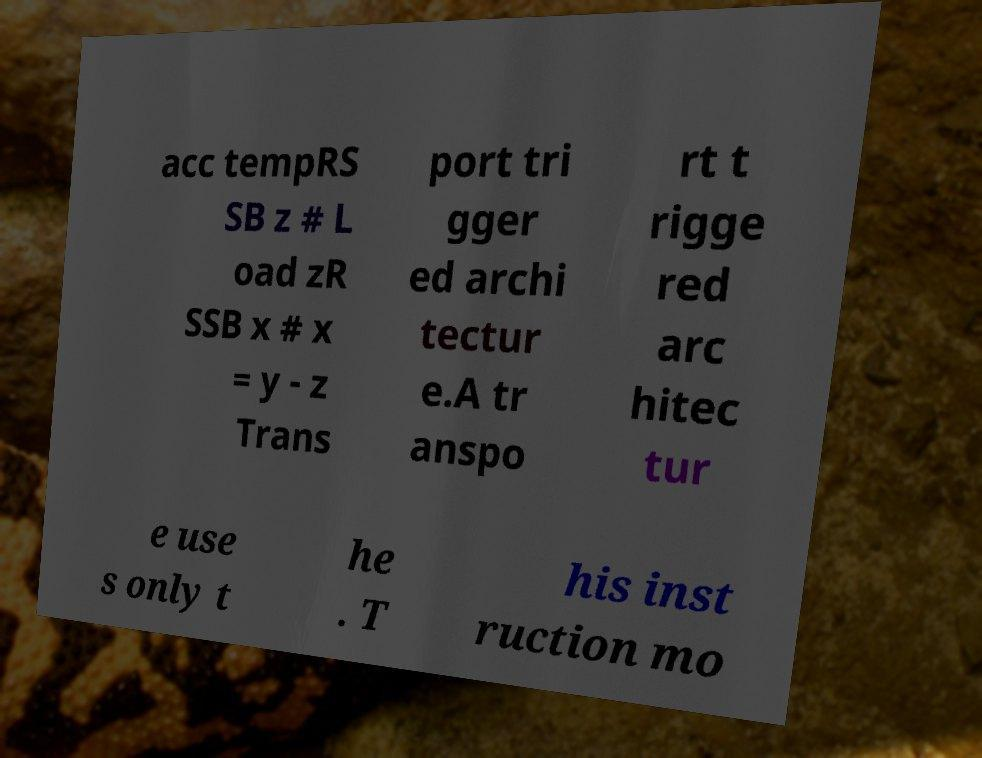There's text embedded in this image that I need extracted. Can you transcribe it verbatim? acc tempRS SB z # L oad zR SSB x # x = y - z Trans port tri gger ed archi tectur e.A tr anspo rt t rigge red arc hitec tur e use s only t he . T his inst ruction mo 